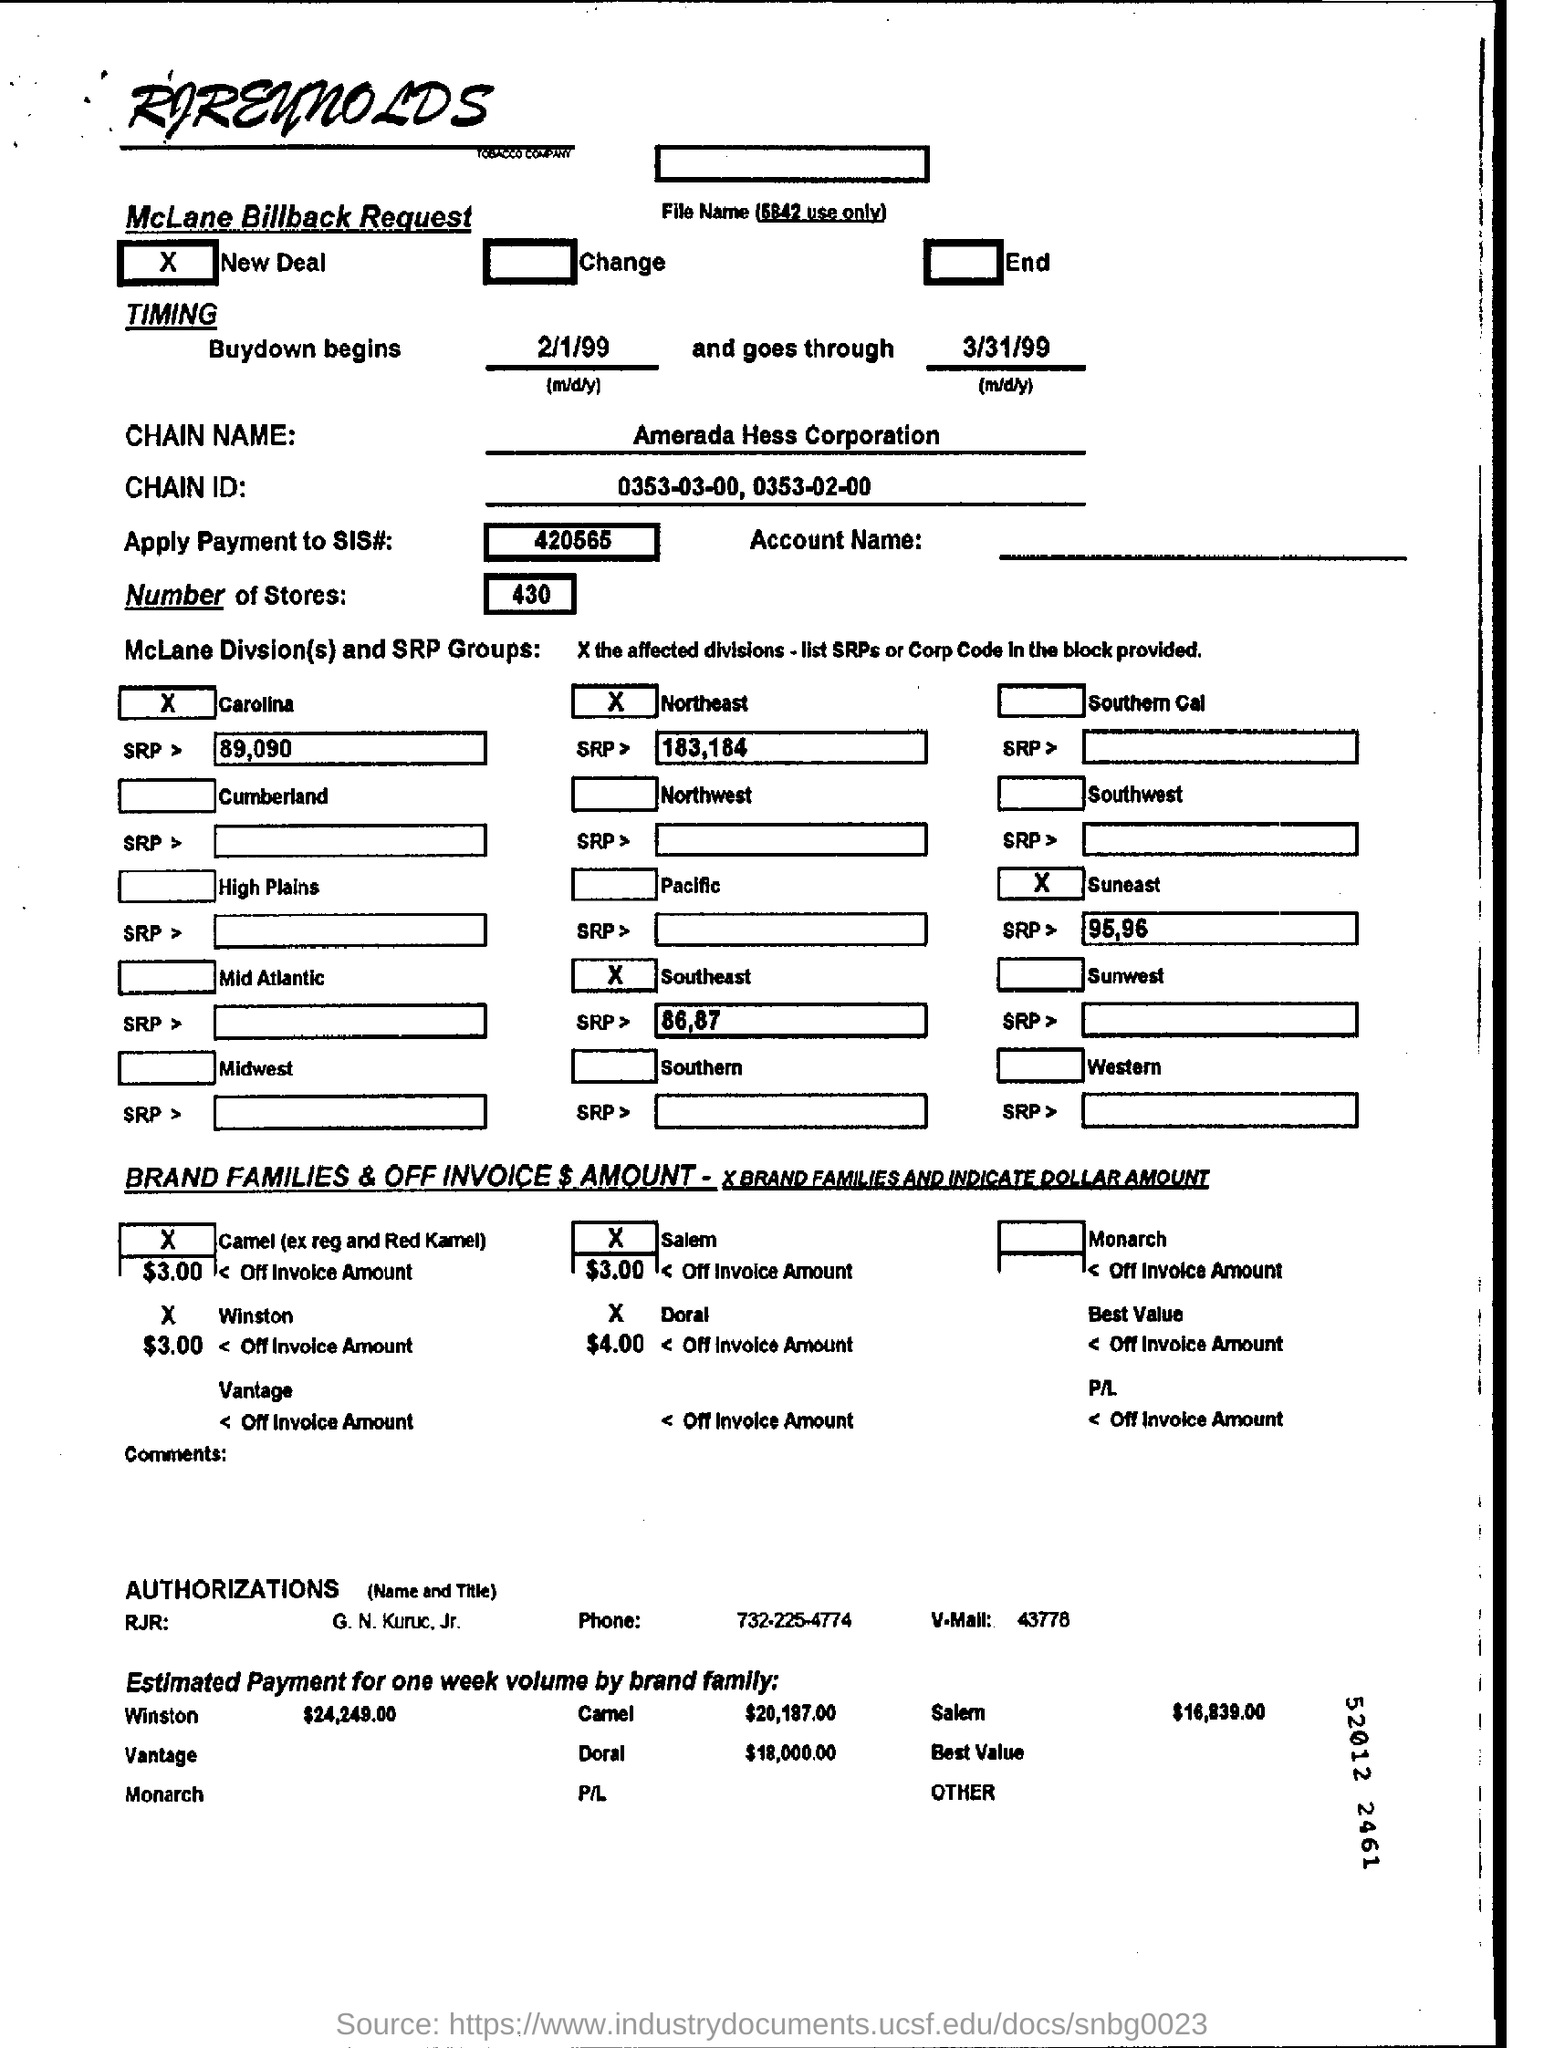List a handful of essential elements in this visual. The chain name is Amerada Hess Corporation. There are 430 stores. The chain ID is 0353-03-00, 0353-02-00, and so on. 